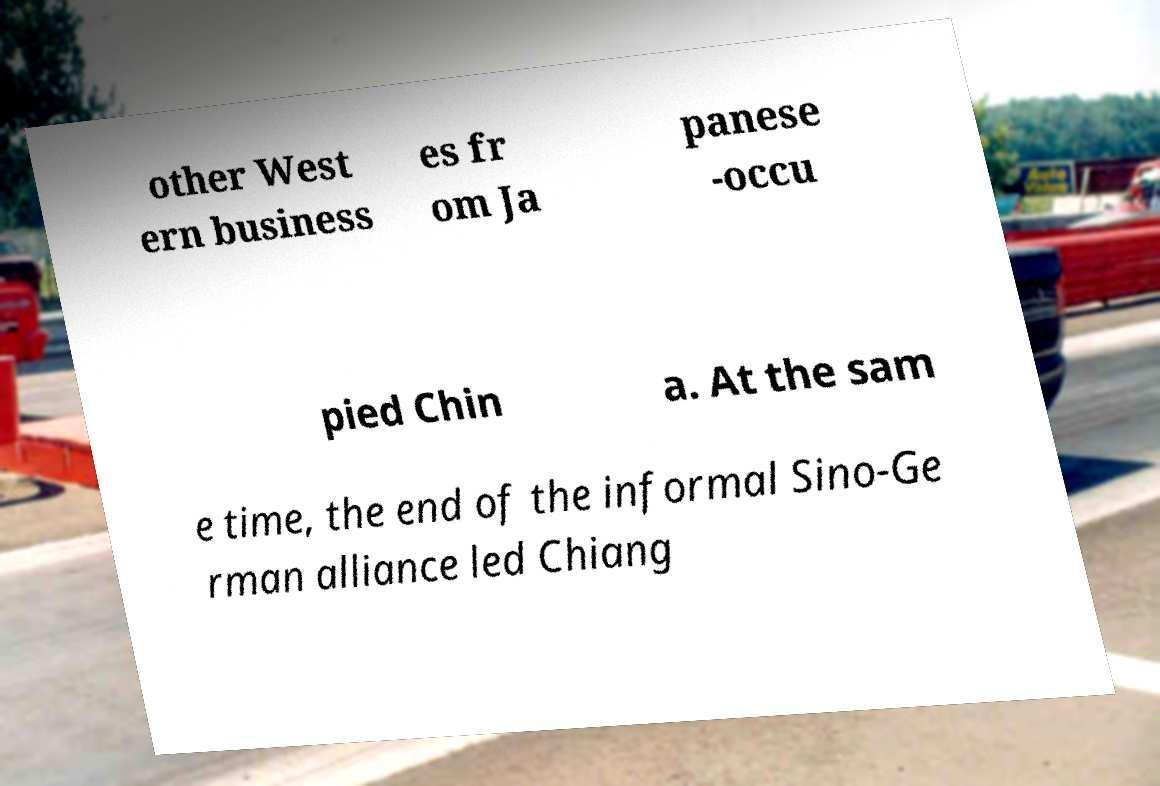Please read and relay the text visible in this image. What does it say? other West ern business es fr om Ja panese -occu pied Chin a. At the sam e time, the end of the informal Sino-Ge rman alliance led Chiang 